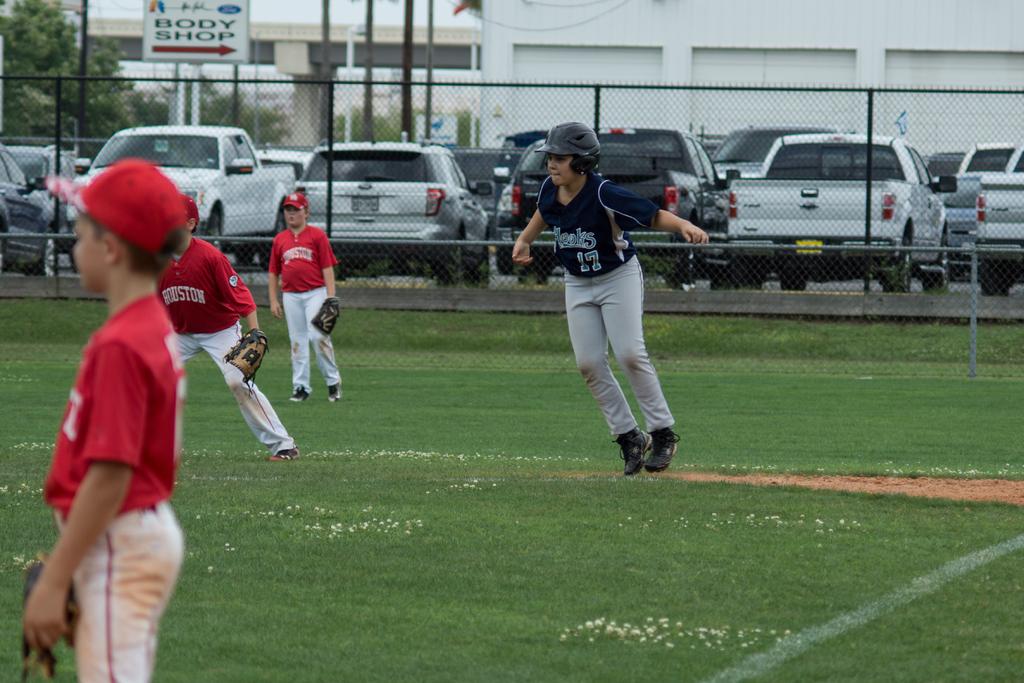What is the blue jersey number?
Your answer should be very brief. 17. 